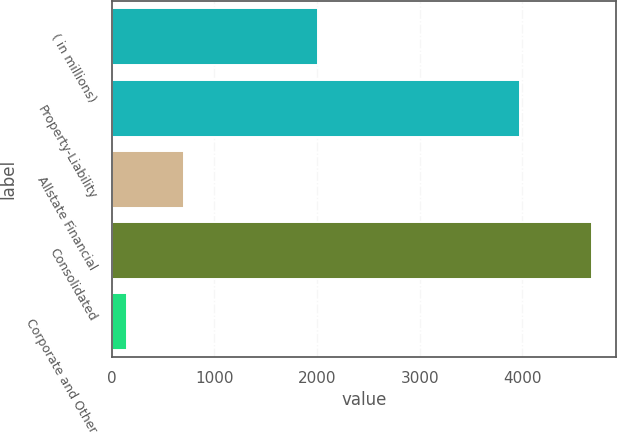Convert chart to OTSL. <chart><loc_0><loc_0><loc_500><loc_500><bar_chart><fcel>( in millions)<fcel>Property-Liability<fcel>Allstate Financial<fcel>Consolidated<fcel>Corporate and Other<nl><fcel>2008<fcel>3975<fcel>704<fcel>4679<fcel>144<nl></chart> 